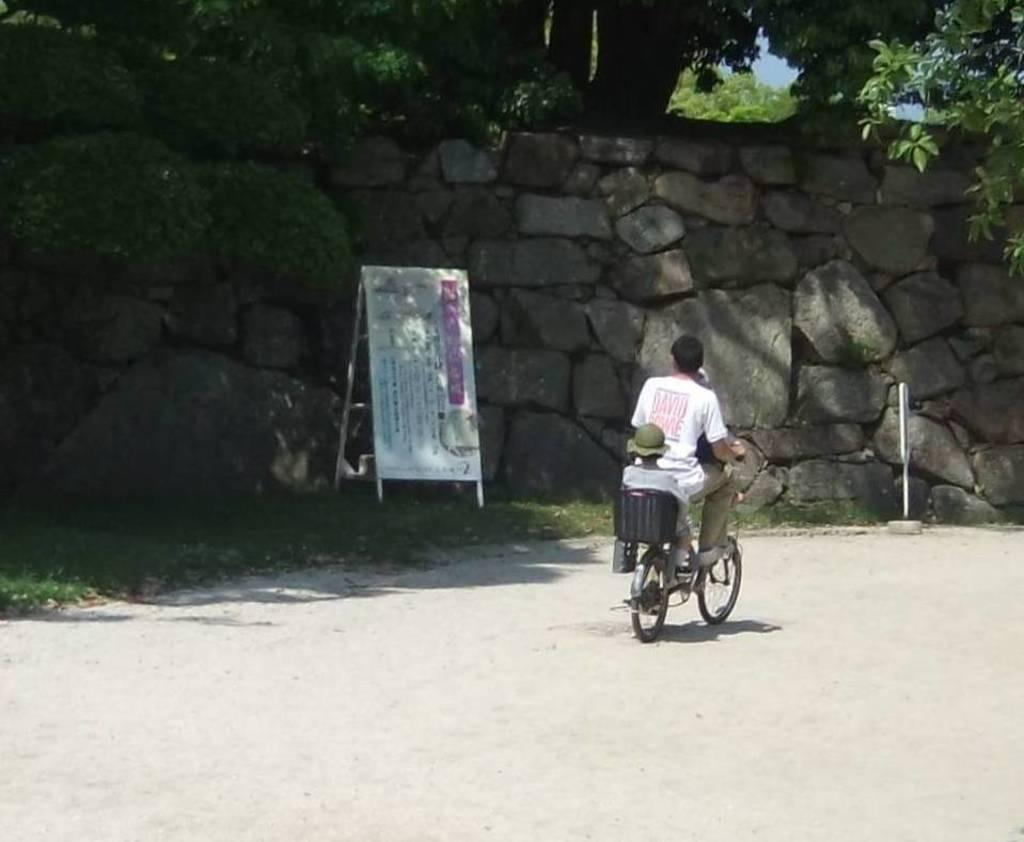What is the main subject of the image? There is a person riding a bicycle in the image. What is located to the left of the person? There is a board to the left of the person. What type of natural environment is visible in the image? There are trees visible in the image. What other object can be seen in the image? There is a rock in the image. How many vases are present in the image? There are no vases present in the image. What type of pollution can be seen in the image? There is no pollution visible in the image. 